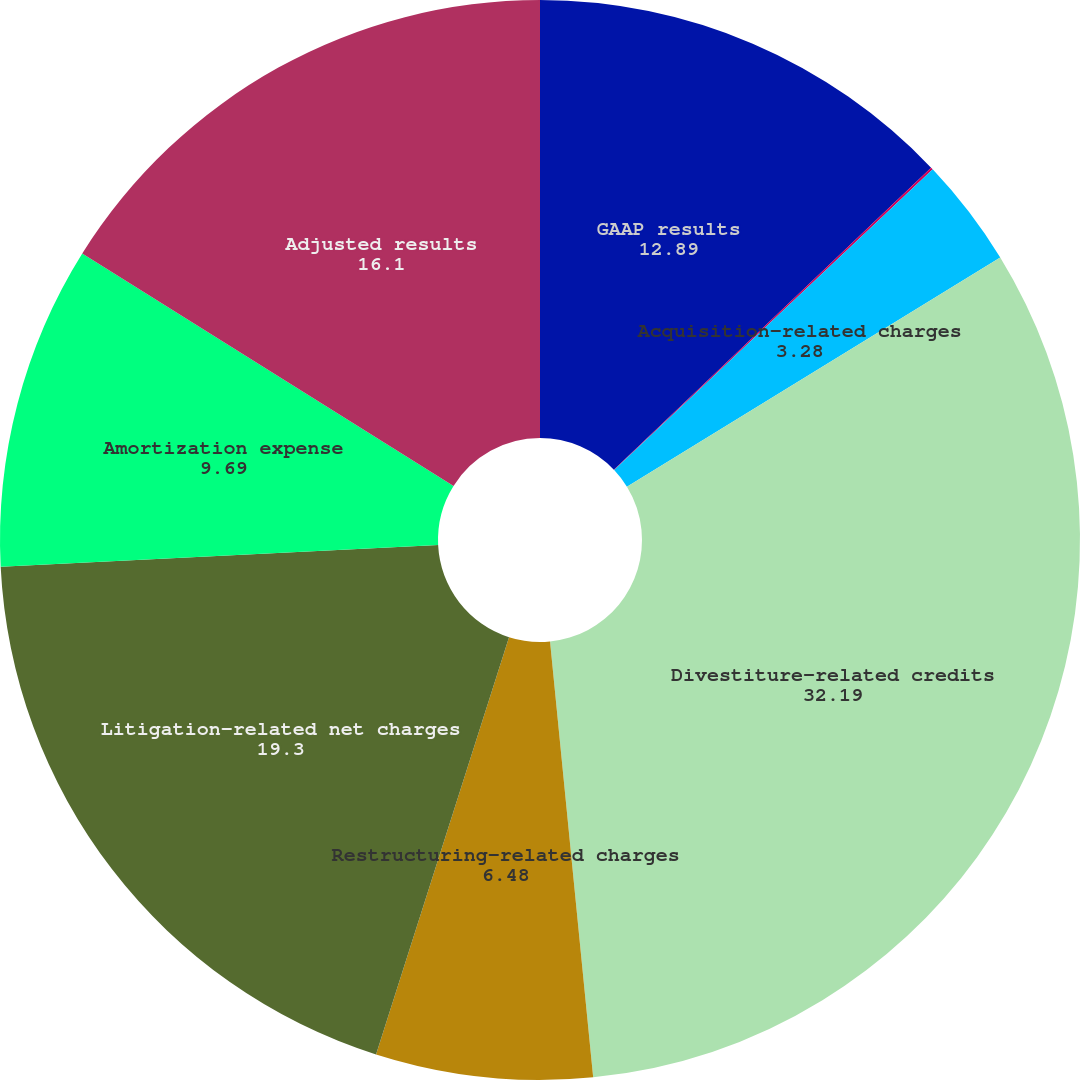Convert chart. <chart><loc_0><loc_0><loc_500><loc_500><pie_chart><fcel>GAAP results<fcel>Intangible asset impairment<fcel>Acquisition-related charges<fcel>Divestiture-related credits<fcel>Restructuring-related charges<fcel>Litigation-related net charges<fcel>Amortization expense<fcel>Adjusted results<nl><fcel>12.89%<fcel>0.07%<fcel>3.28%<fcel>32.19%<fcel>6.48%<fcel>19.3%<fcel>9.69%<fcel>16.1%<nl></chart> 